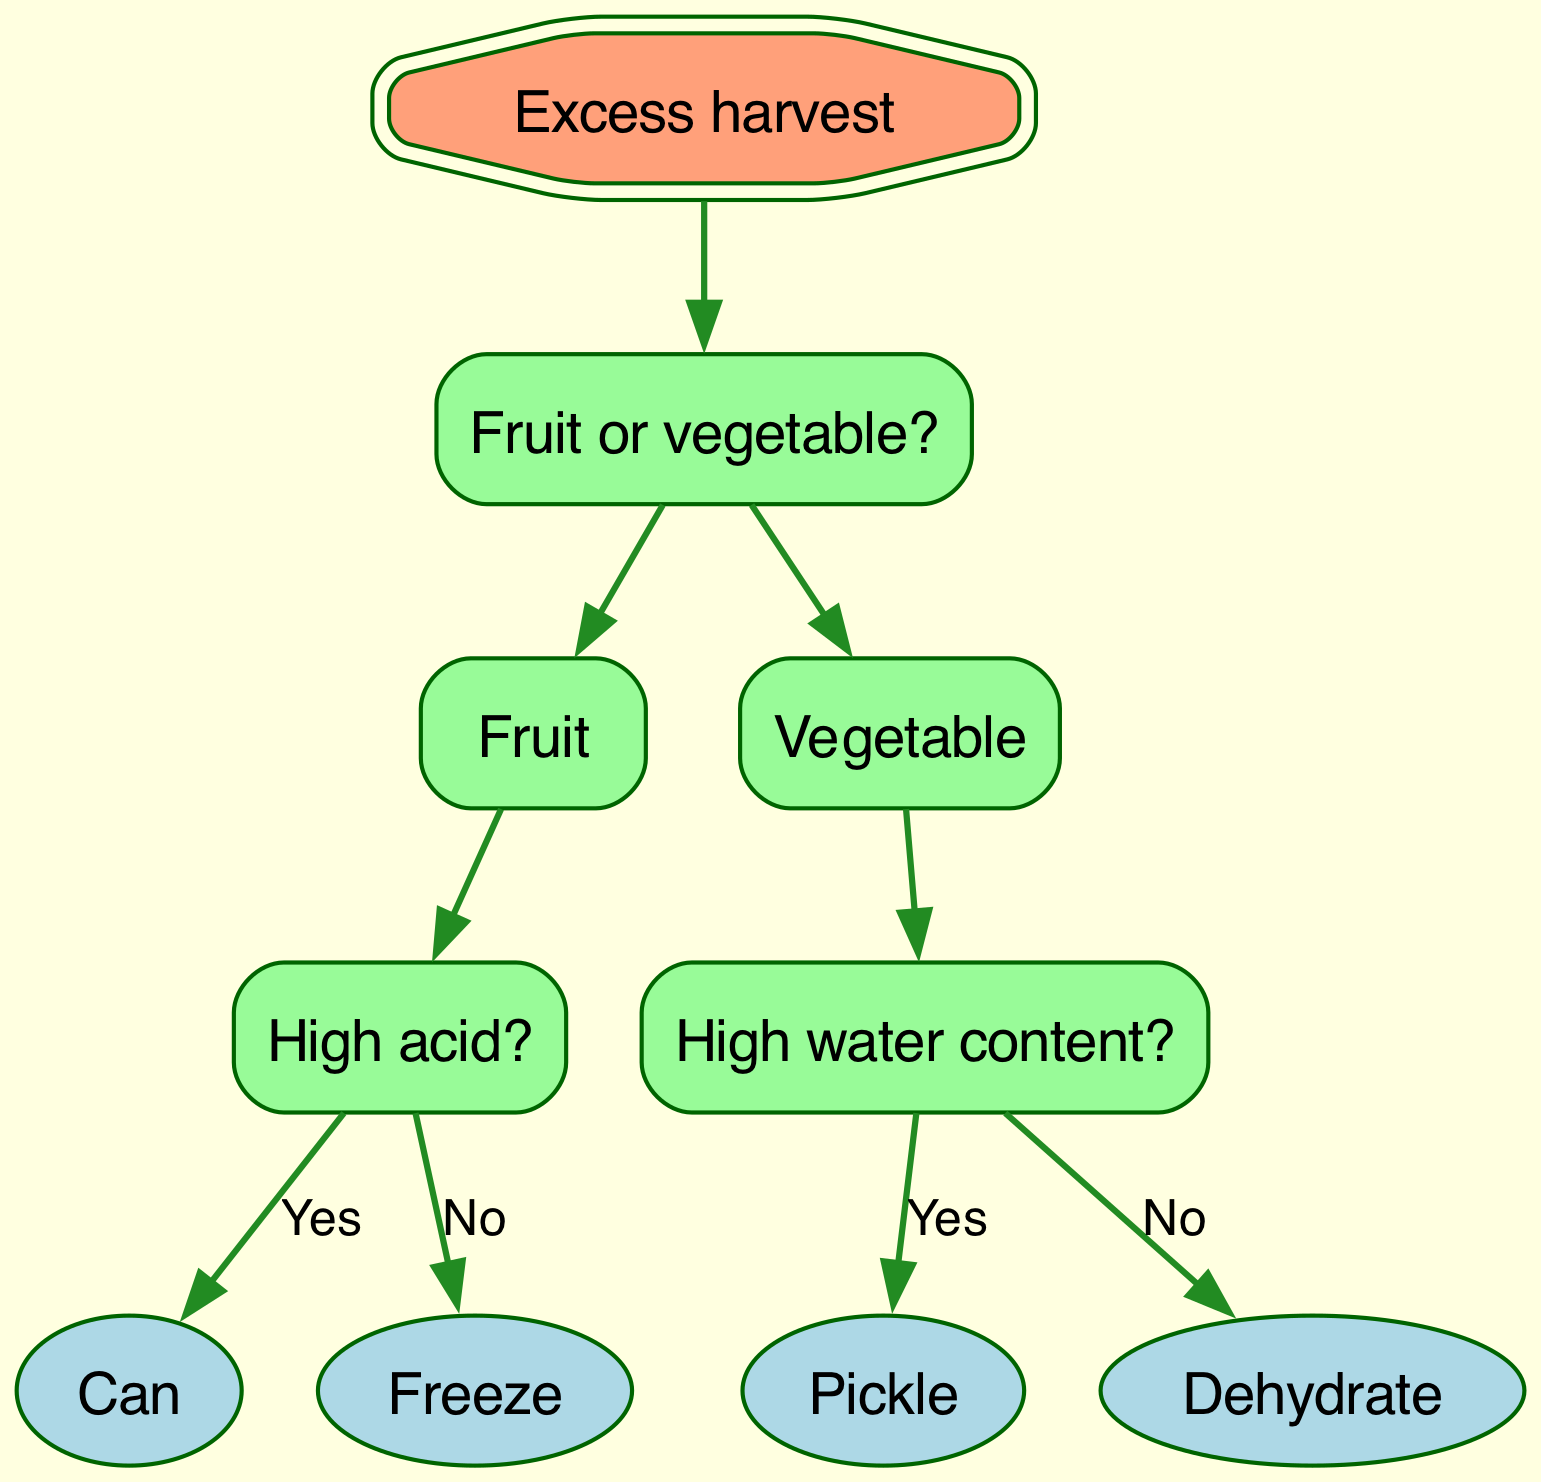What is the root node of the diagram? The root node of the diagram is labeled "Excess harvest". This is the starting point from which all decisions branch out.
Answer: Excess harvest How many main branches are there extending from the root node? There are two main branches extending from the root node: "Fruit or vegetable?". This indicates two primary categories for preservation decisions.
Answer: 2 What is the final recommendation for high acid fruit? If the fruit is high acid, the recommended preservation method is "Can". This recommendation is reached after identifying it as a fruit and confirming its high acid content.
Answer: Can If the vegetable has high water content, what is the recommended method? For vegetables with high water content, the recommended method is "Pickle". This follows the decision path after identifying it as a vegetable and confirming the water content level.
Answer: Pickle What preservation method is suggested for low acid fruit? The suggested preservation method for low acid fruit is "Freeze". This conclusion comes from identifying the item as fruit first and then determining its low acid content.
Answer: Freeze What is the recommended method for vegetables with low water content? The recommended method for vegetables with low water content is "Dehydrate". This is determined after categorizing it as a vegetable and confirming that it does not have high water content.
Answer: Dehydrate What type of diagram is this? This is a Decision Tree diagram. Its structure allows for making decisions based on conditions to lead to specific recommendations.
Answer: Decision Tree What happens if the harvest you have is a low water content vegetable? If the harvest is classified as a low water content vegetable, the flow of decisions leads to the recommendation to "Dehydrate" it for preservation.
Answer: Dehydrate How is the "High water content?" decision node related to vegetables in the diagram? The "High water content?" decision node is a split that specifically follows the identification of the harvest as a vegetable and determines the suitable preservation method based on the water content.
Answer: Related to vegetable decision node 